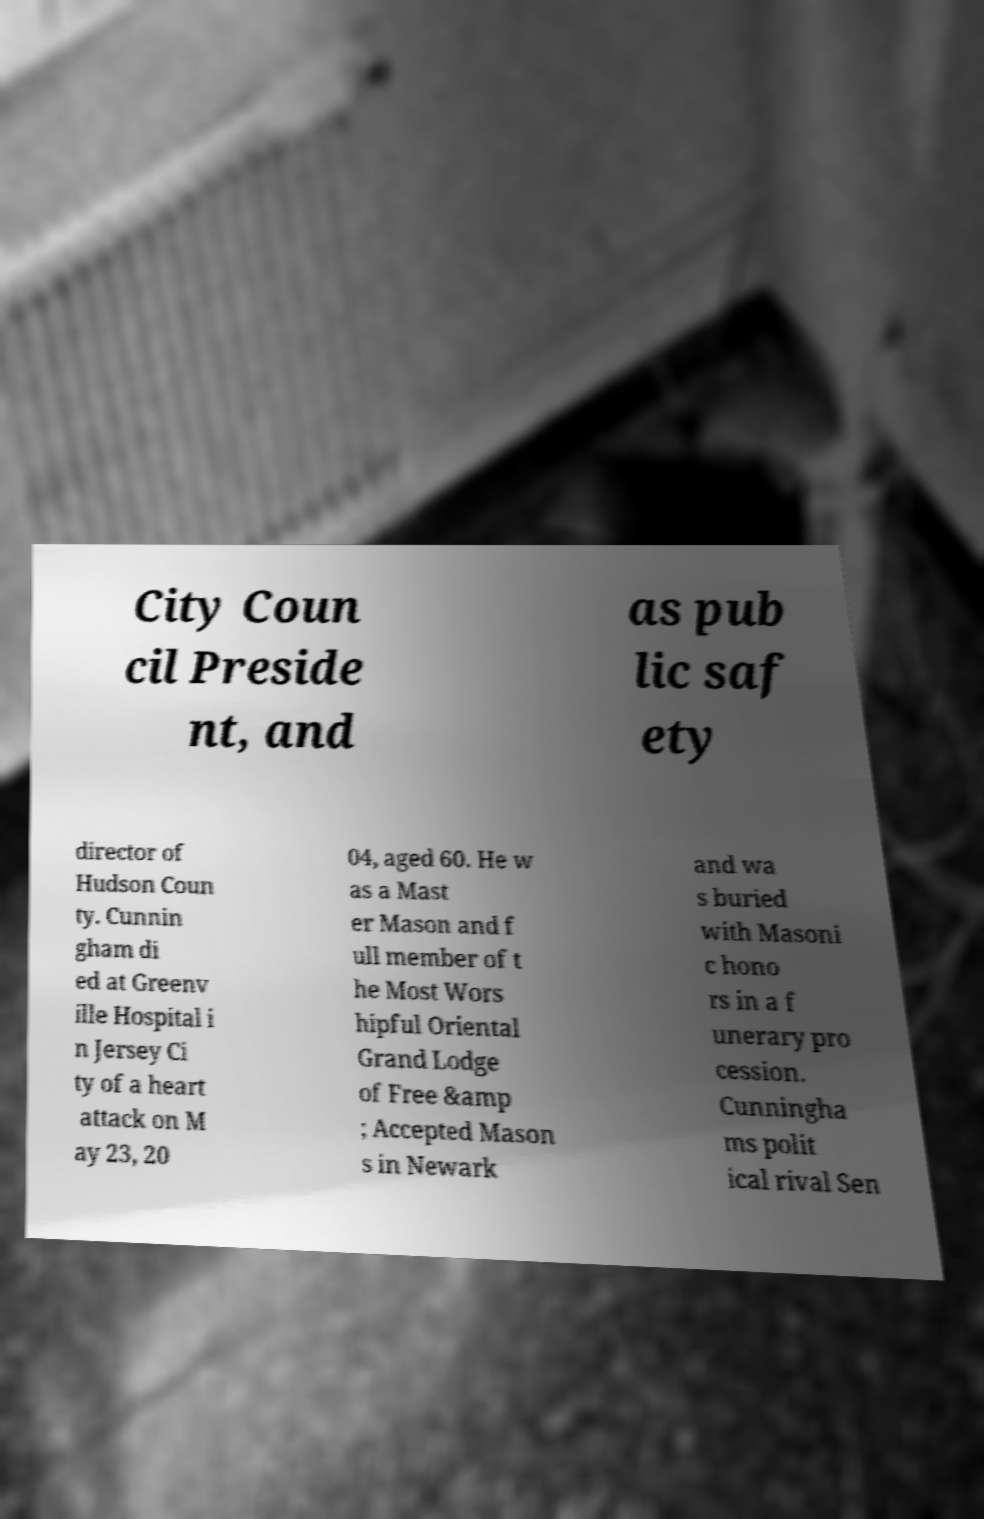For documentation purposes, I need the text within this image transcribed. Could you provide that? City Coun cil Preside nt, and as pub lic saf ety director of Hudson Coun ty. Cunnin gham di ed at Greenv ille Hospital i n Jersey Ci ty of a heart attack on M ay 23, 20 04, aged 60. He w as a Mast er Mason and f ull member of t he Most Wors hipful Oriental Grand Lodge of Free &amp ; Accepted Mason s in Newark and wa s buried with Masoni c hono rs in a f unerary pro cession. Cunningha ms polit ical rival Sen 